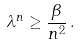Convert formula to latex. <formula><loc_0><loc_0><loc_500><loc_500>\lambda ^ { n } \geq \frac { \beta } { n ^ { 2 } } \, .</formula> 